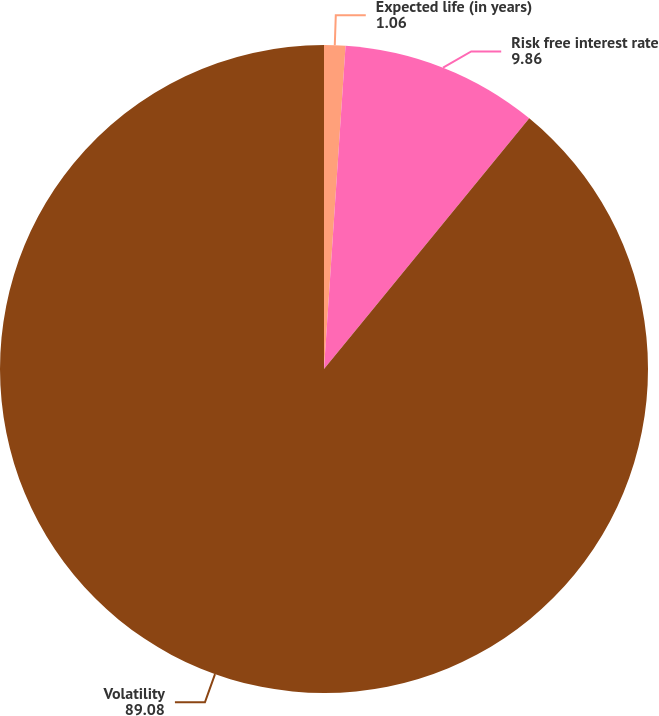Convert chart to OTSL. <chart><loc_0><loc_0><loc_500><loc_500><pie_chart><fcel>Expected life (in years)<fcel>Risk free interest rate<fcel>Volatility<nl><fcel>1.06%<fcel>9.86%<fcel>89.08%<nl></chart> 